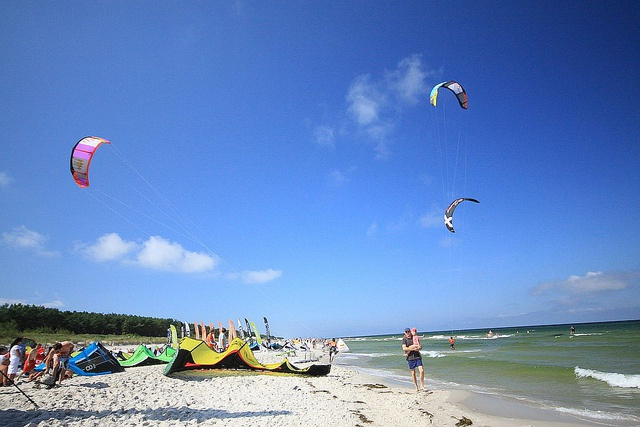Describe the objects in this image and their specific colors. I can see kite in blue, violet, white, and gray tones, people in blue, black, maroon, and gray tones, people in blue, gray, black, and tan tones, kite in blue, black, gray, and lightblue tones, and people in blue, black, lavender, darkgray, and maroon tones in this image. 